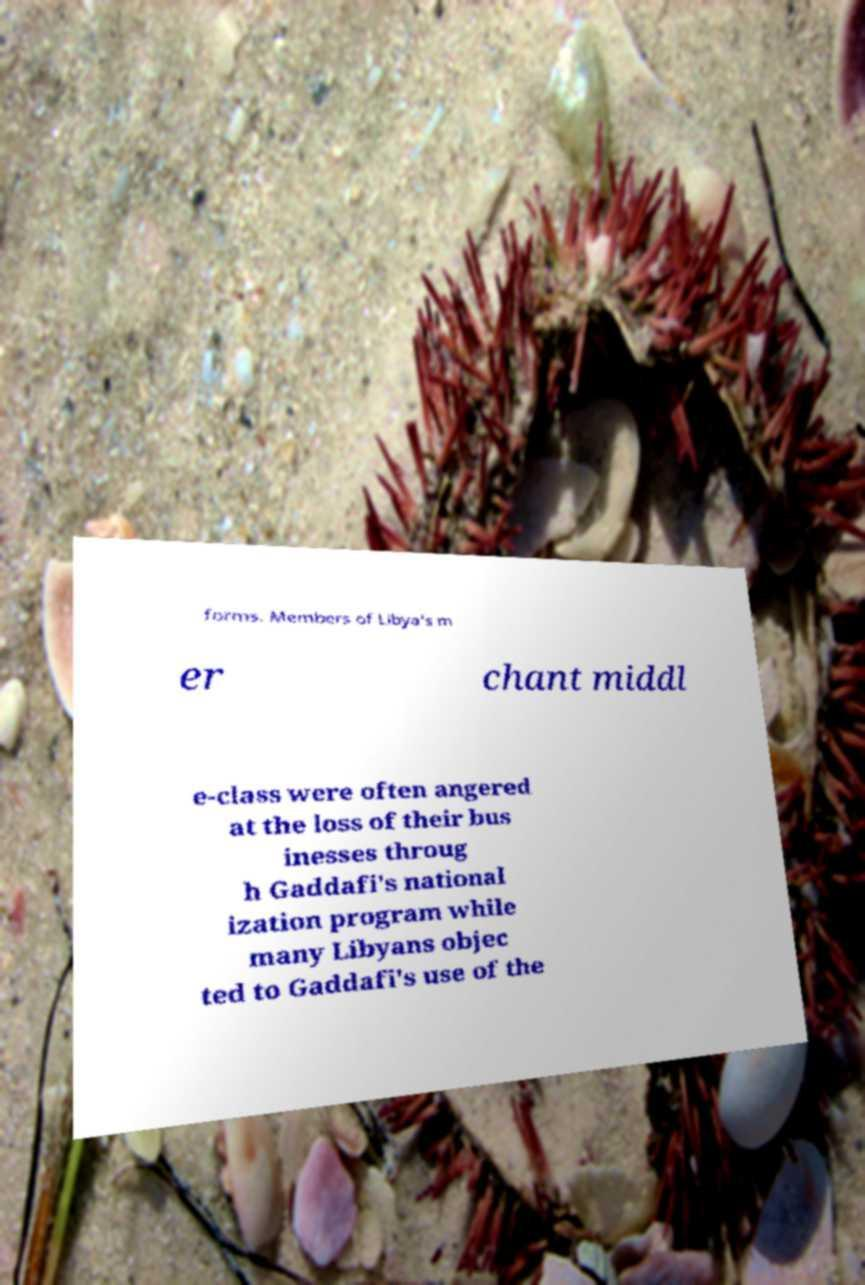There's text embedded in this image that I need extracted. Can you transcribe it verbatim? forms. Members of Libya's m er chant middl e-class were often angered at the loss of their bus inesses throug h Gaddafi's national ization program while many Libyans objec ted to Gaddafi's use of the 